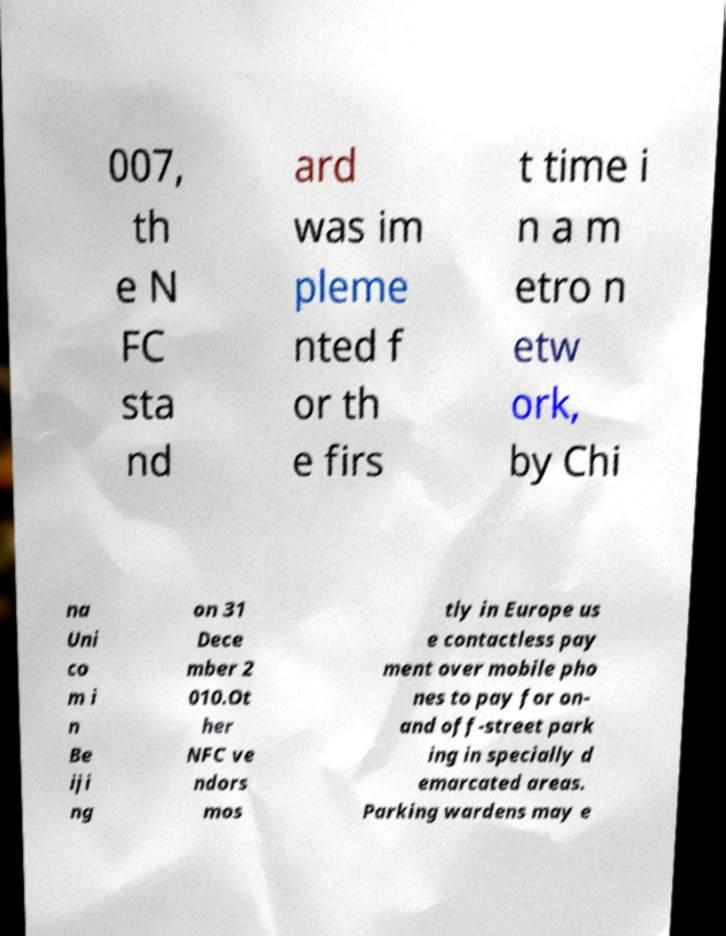Could you extract and type out the text from this image? 007, th e N FC sta nd ard was im pleme nted f or th e firs t time i n a m etro n etw ork, by Chi na Uni co m i n Be iji ng on 31 Dece mber 2 010.Ot her NFC ve ndors mos tly in Europe us e contactless pay ment over mobile pho nes to pay for on- and off-street park ing in specially d emarcated areas. Parking wardens may e 